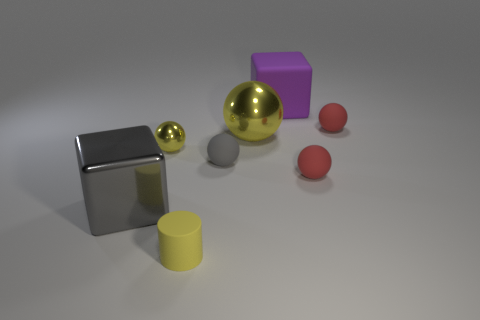Is there anything else that is the same shape as the yellow rubber thing?
Provide a succinct answer. No. Is there a brown thing that has the same shape as the big gray object?
Make the answer very short. No. What material is the gray ball?
Your answer should be very brief. Rubber. There is a matte ball that is both in front of the big yellow metallic ball and to the right of the big yellow metal ball; what size is it?
Make the answer very short. Small. There is a big object that is the same color as the matte cylinder; what is its material?
Your answer should be very brief. Metal. How many yellow cylinders are there?
Offer a very short reply. 1. Is the number of brown cylinders less than the number of big purple blocks?
Provide a succinct answer. Yes. What material is the yellow thing that is the same size as the cylinder?
Make the answer very short. Metal. What number of objects are large yellow metal cubes or red rubber objects?
Your answer should be compact. 2. What number of things are both right of the big yellow sphere and left of the purple rubber object?
Your response must be concise. 0. 